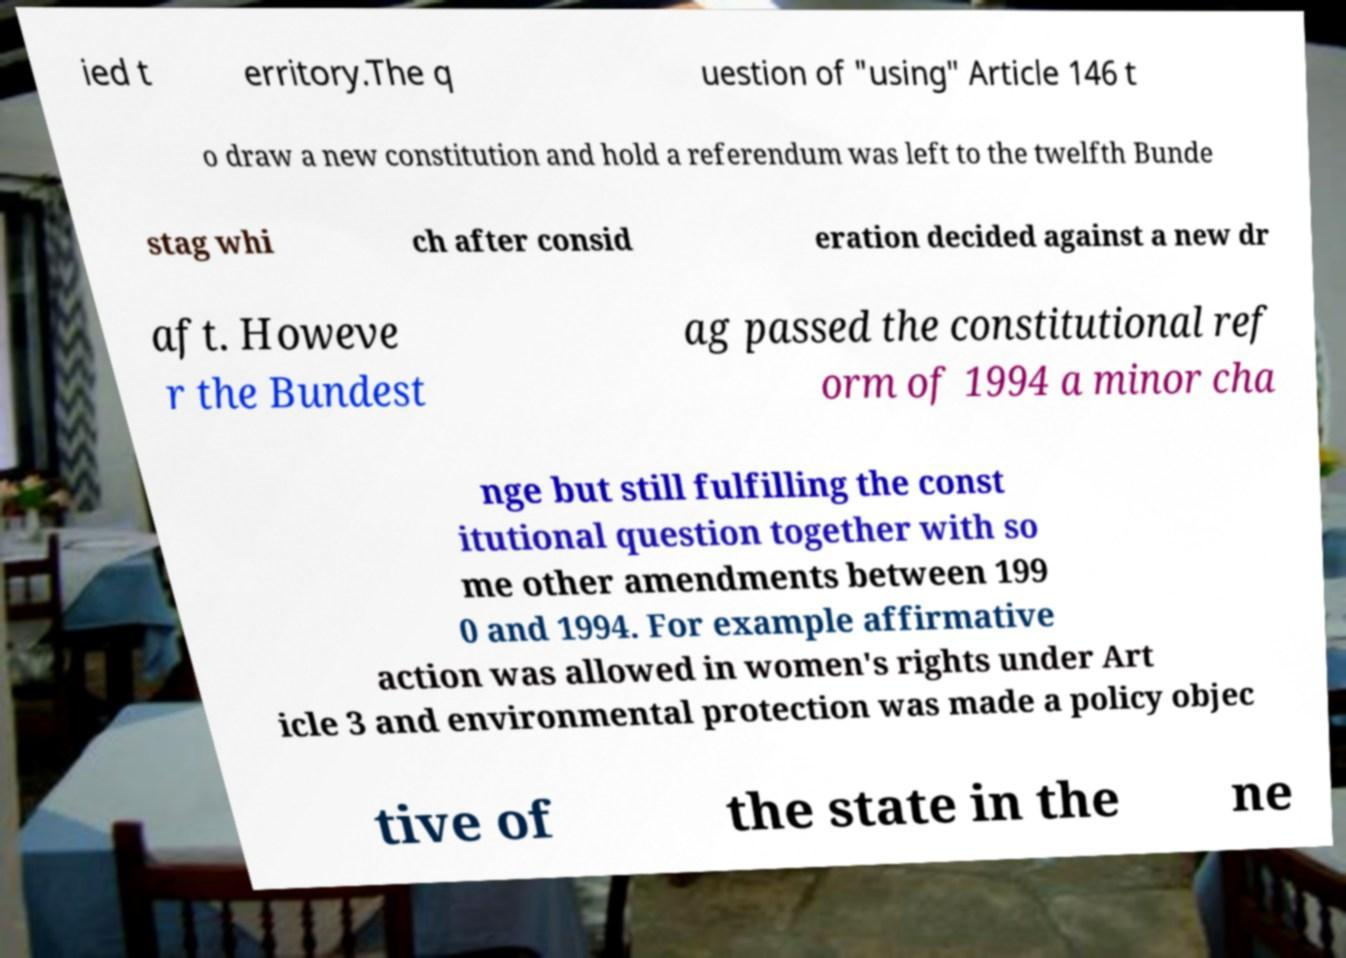I need the written content from this picture converted into text. Can you do that? ied t erritory.The q uestion of "using″ Article 146 t o draw a new constitution and hold a referendum was left to the twelfth Bunde stag whi ch after consid eration decided against a new dr aft. Howeve r the Bundest ag passed the constitutional ref orm of 1994 a minor cha nge but still fulfilling the const itutional question together with so me other amendments between 199 0 and 1994. For example affirmative action was allowed in women's rights under Art icle 3 and environmental protection was made a policy objec tive of the state in the ne 